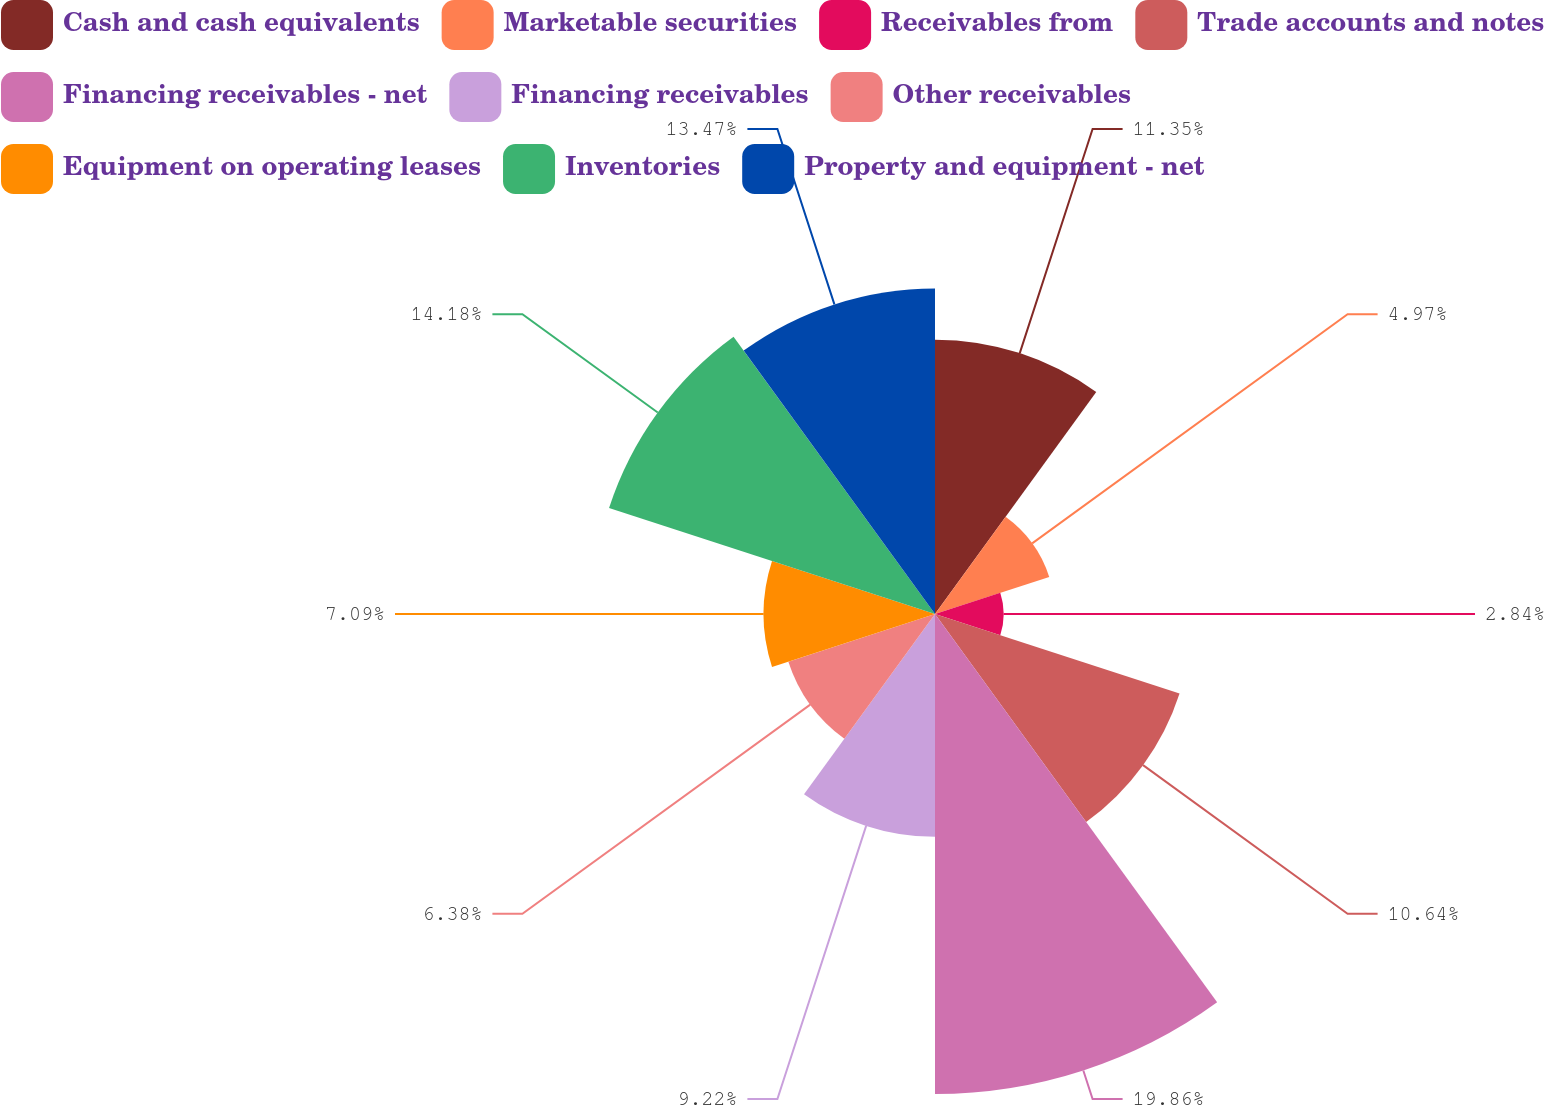Convert chart to OTSL. <chart><loc_0><loc_0><loc_500><loc_500><pie_chart><fcel>Cash and cash equivalents<fcel>Marketable securities<fcel>Receivables from<fcel>Trade accounts and notes<fcel>Financing receivables - net<fcel>Financing receivables<fcel>Other receivables<fcel>Equipment on operating leases<fcel>Inventories<fcel>Property and equipment - net<nl><fcel>11.35%<fcel>4.97%<fcel>2.84%<fcel>10.64%<fcel>19.86%<fcel>9.22%<fcel>6.38%<fcel>7.09%<fcel>14.18%<fcel>13.47%<nl></chart> 